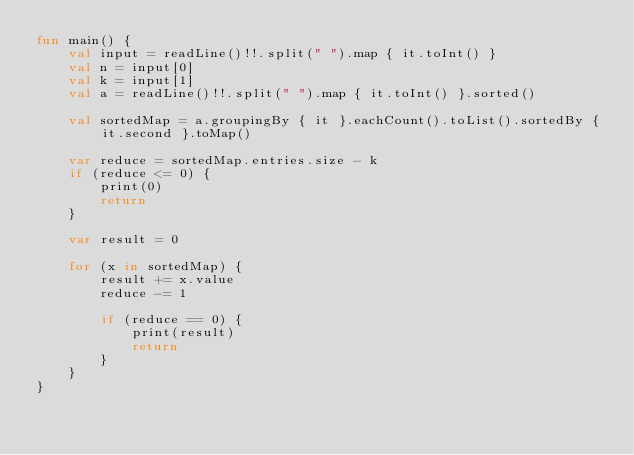<code> <loc_0><loc_0><loc_500><loc_500><_Kotlin_>fun main() {
    val input = readLine()!!.split(" ").map { it.toInt() }
    val n = input[0]
    val k = input[1]
    val a = readLine()!!.split(" ").map { it.toInt() }.sorted()

    val sortedMap = a.groupingBy { it }.eachCount().toList().sortedBy { it.second }.toMap()

    var reduce = sortedMap.entries.size - k
    if (reduce <= 0) {
        print(0)
        return
    }

    var result = 0

    for (x in sortedMap) {
        result += x.value
        reduce -= 1

        if (reduce == 0) {
            print(result)
            return
        }
    }
}
</code> 